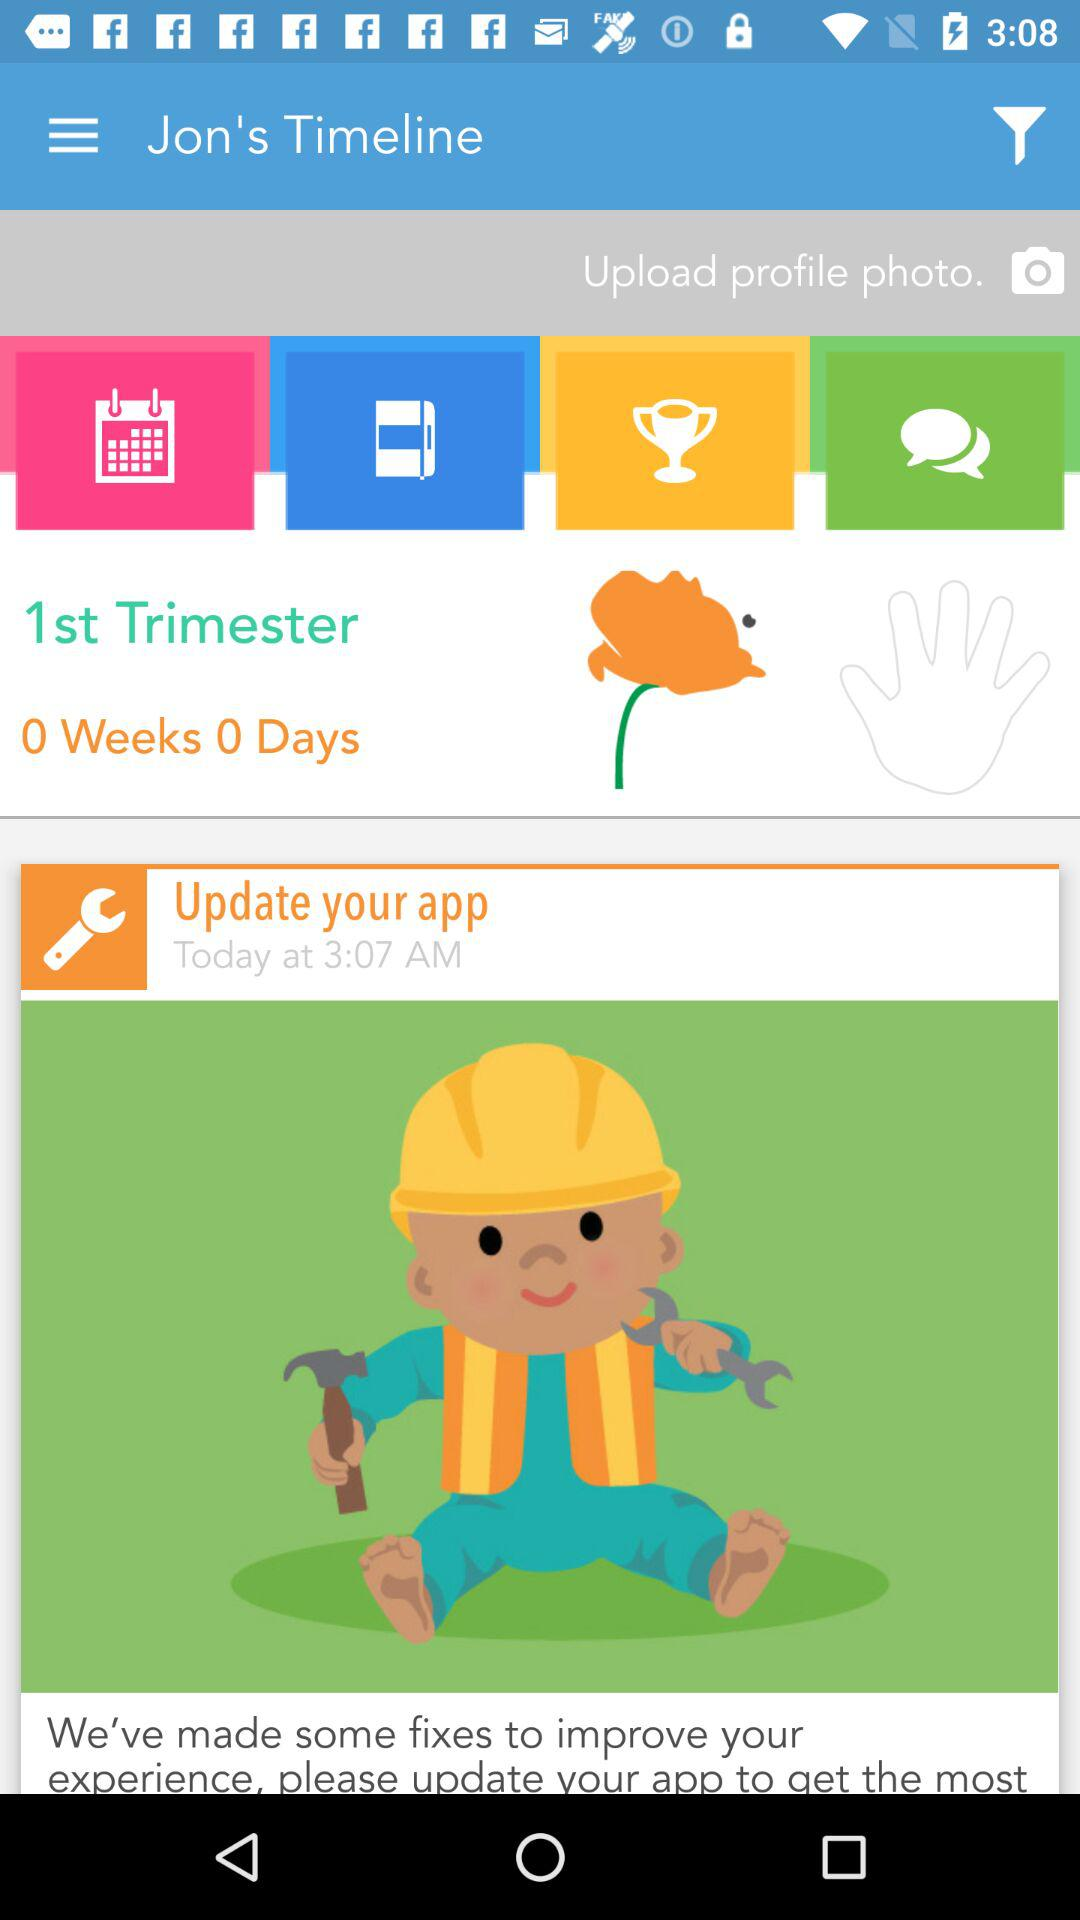What is the shown duration? The shown duration is 0 week and 0 day. 